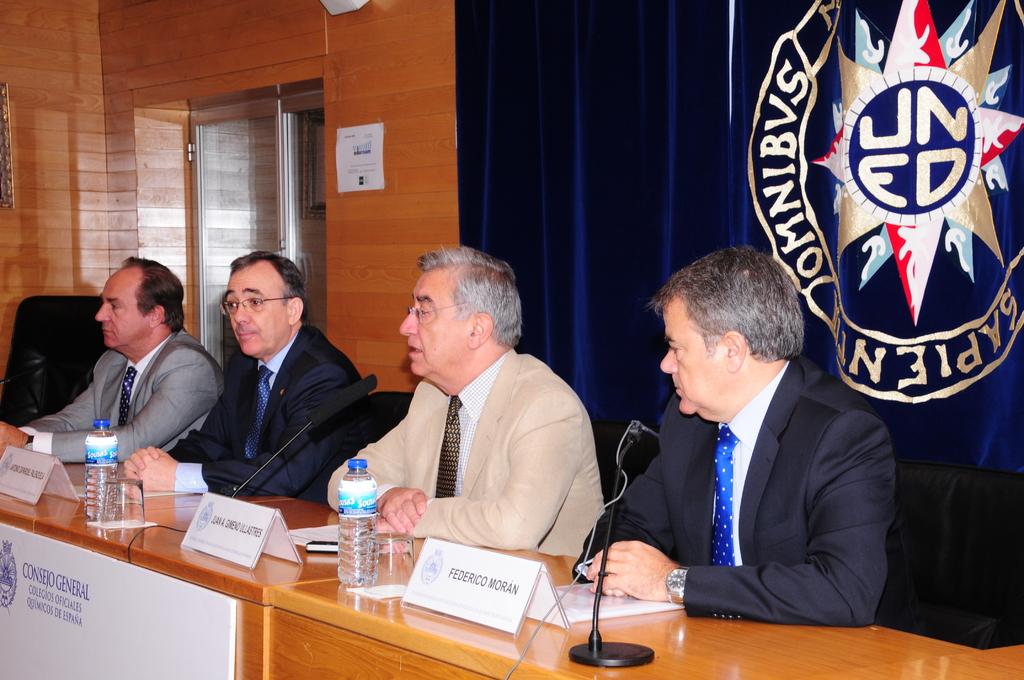Who is sitting on the far right?
Offer a very short reply. Federico moran. What are the 4 letters in the circle?
Make the answer very short. Uned. 